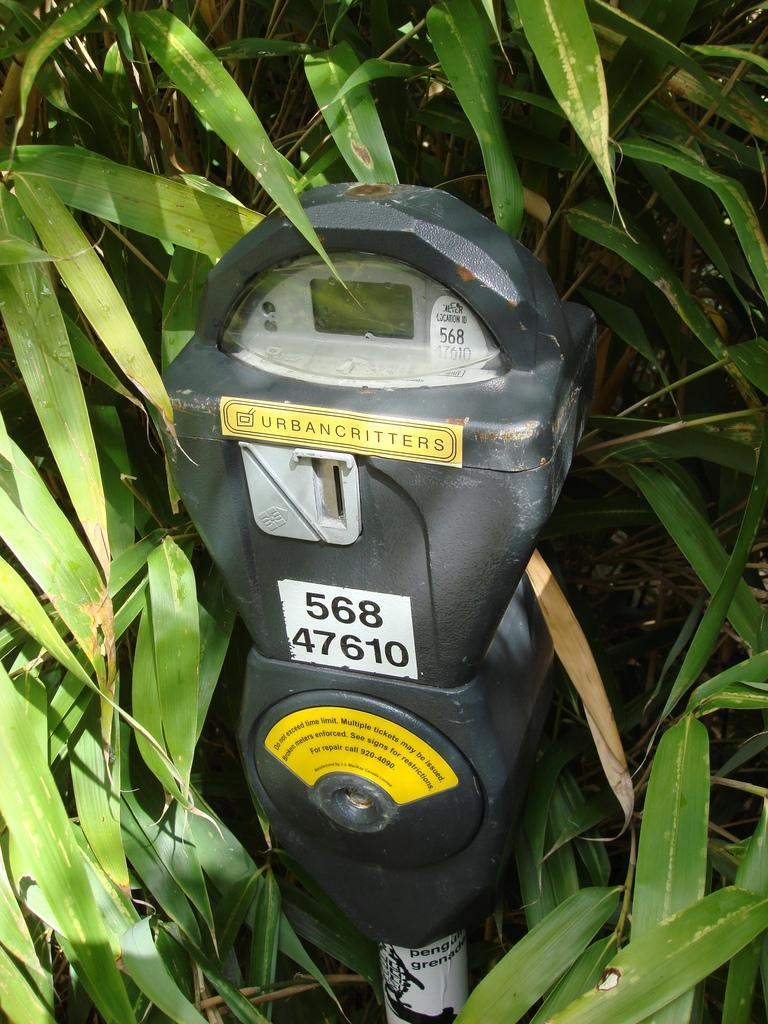Provide a one-sentence caption for the provided image. A parking meter is obscured by foilage and has a sticker upon it which says Urbancritters. 